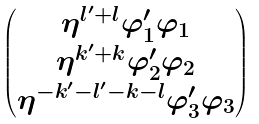Convert formula to latex. <formula><loc_0><loc_0><loc_500><loc_500>\begin{pmatrix} \eta ^ { l ^ { \prime } + l } \varphi ^ { \prime } _ { 1 } \varphi _ { 1 } \\ \eta ^ { k ^ { \prime } + k } \varphi ^ { \prime } _ { 2 } \varphi _ { 2 } \\ \eta ^ { - k ^ { \prime } - l ^ { \prime } - k - l } \varphi ^ { \prime } _ { 3 } \varphi _ { 3 } \end{pmatrix}</formula> 